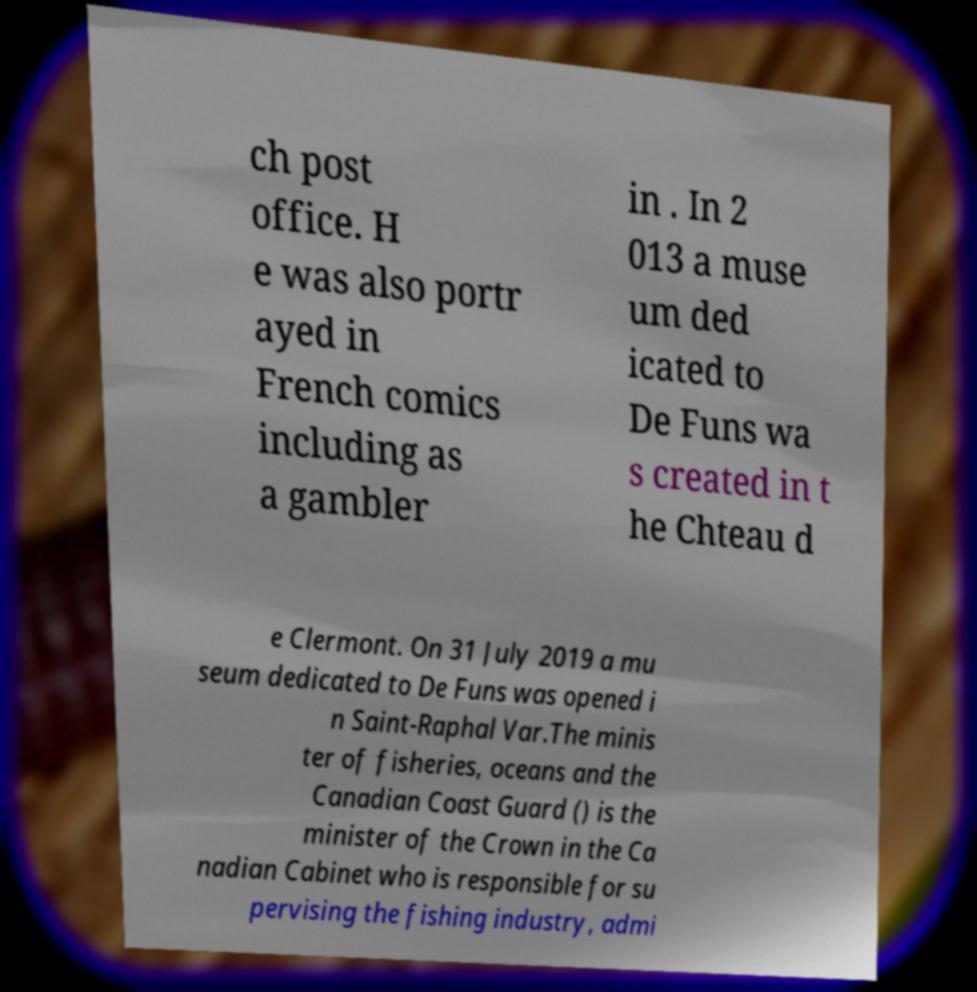For documentation purposes, I need the text within this image transcribed. Could you provide that? ch post office. H e was also portr ayed in French comics including as a gambler in . In 2 013 a muse um ded icated to De Funs wa s created in t he Chteau d e Clermont. On 31 July 2019 a mu seum dedicated to De Funs was opened i n Saint-Raphal Var.The minis ter of fisheries, oceans and the Canadian Coast Guard () is the minister of the Crown in the Ca nadian Cabinet who is responsible for su pervising the fishing industry, admi 